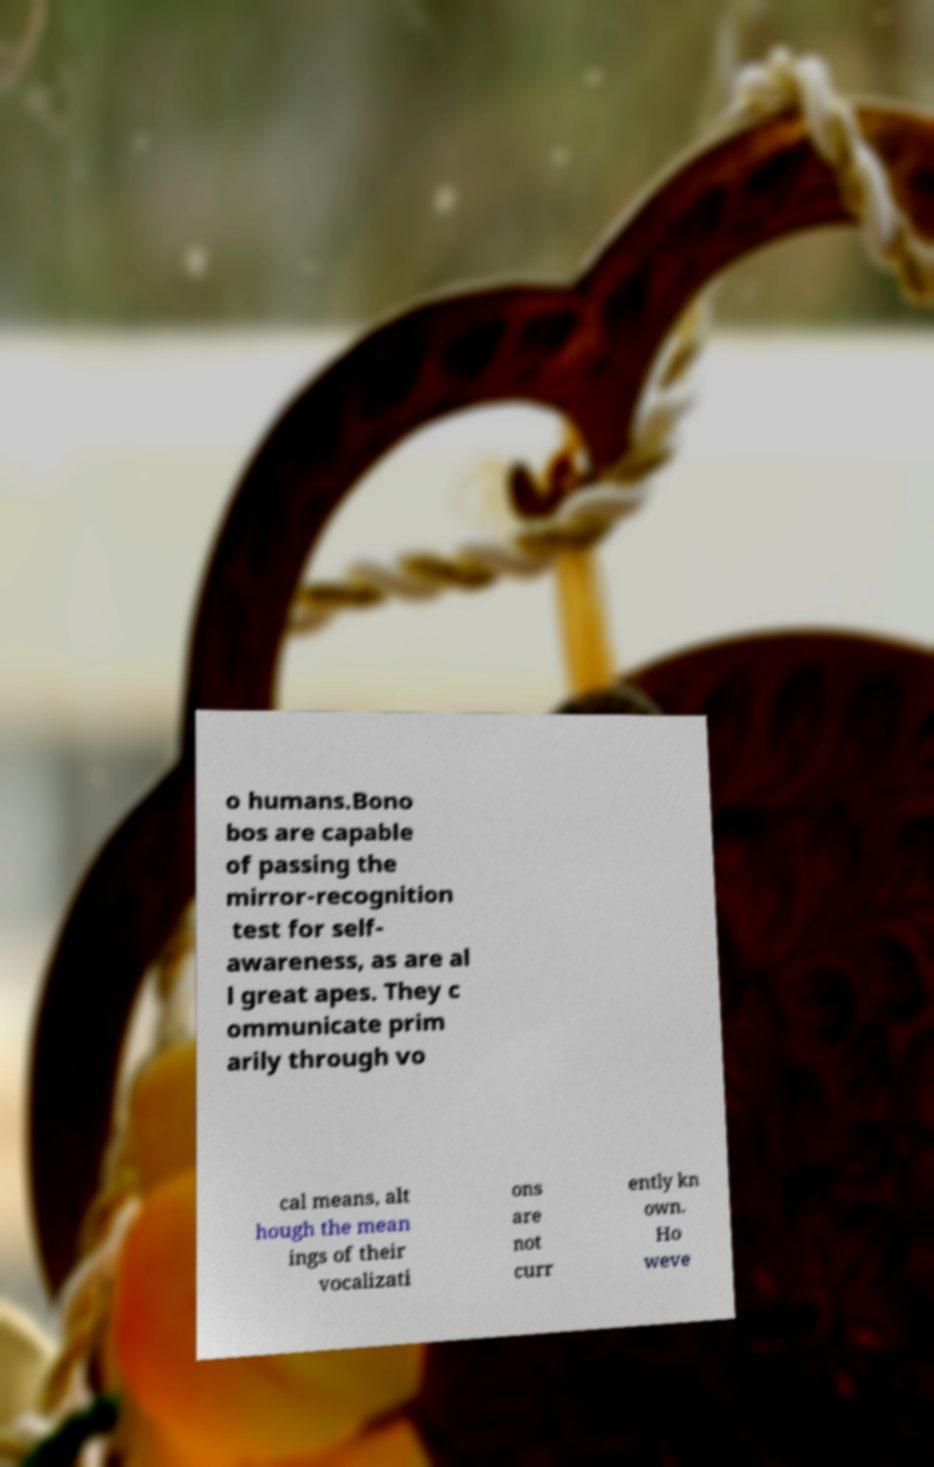Could you assist in decoding the text presented in this image and type it out clearly? o humans.Bono bos are capable of passing the mirror-recognition test for self- awareness, as are al l great apes. They c ommunicate prim arily through vo cal means, alt hough the mean ings of their vocalizati ons are not curr ently kn own. Ho weve 